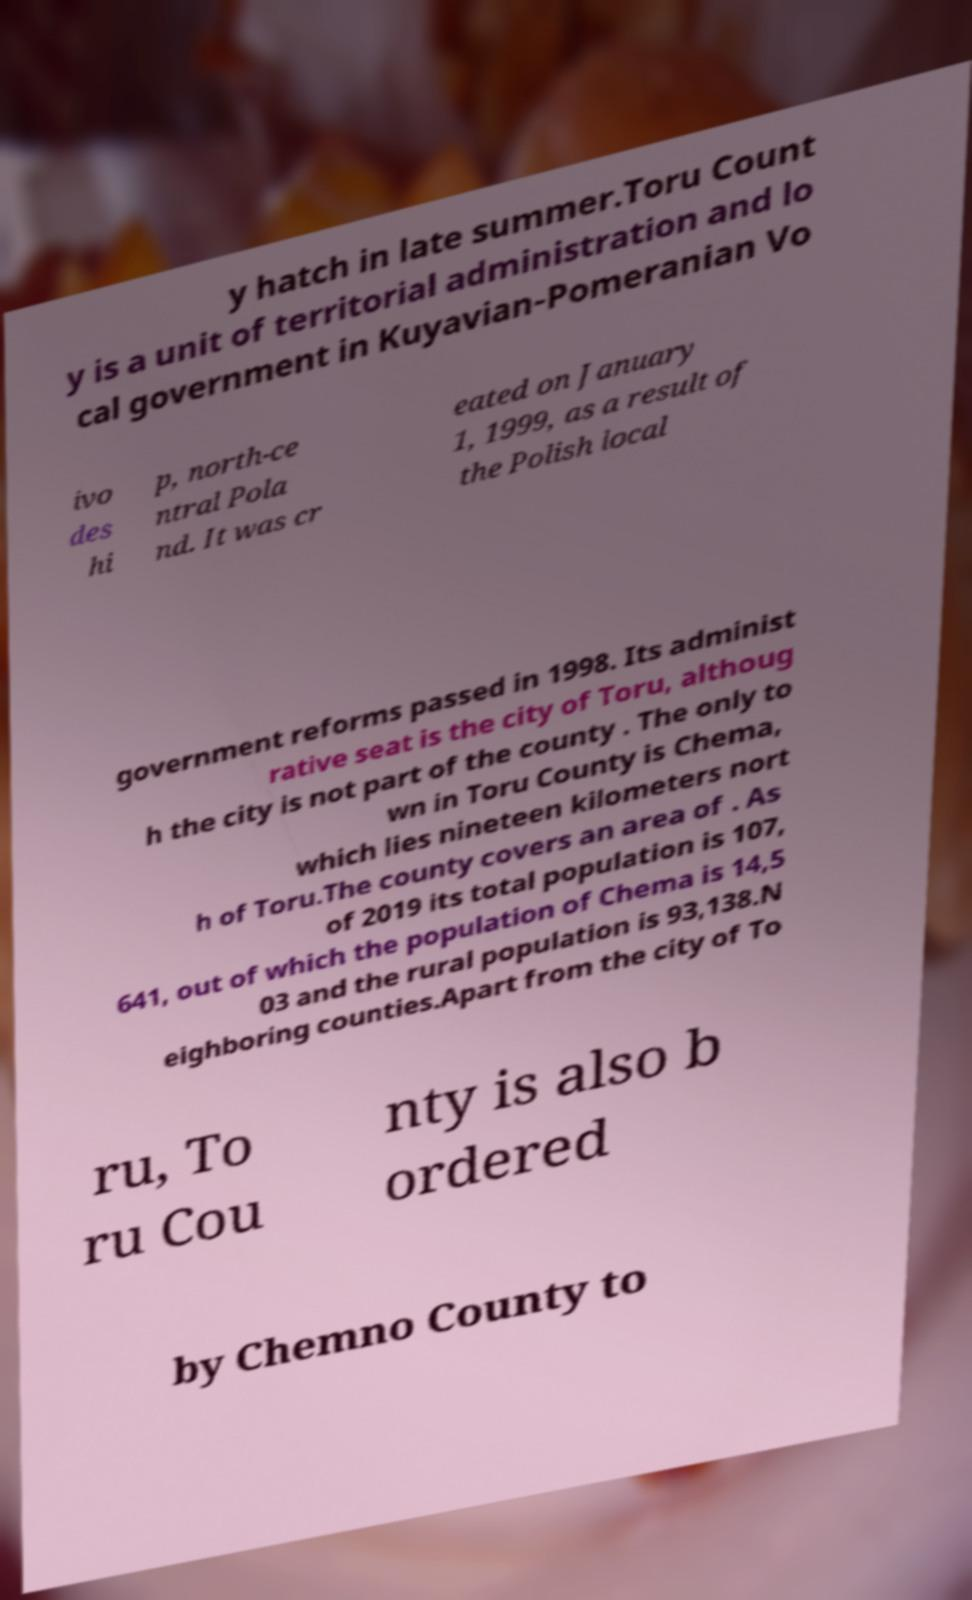There's text embedded in this image that I need extracted. Can you transcribe it verbatim? y hatch in late summer.Toru Count y is a unit of territorial administration and lo cal government in Kuyavian-Pomeranian Vo ivo des hi p, north-ce ntral Pola nd. It was cr eated on January 1, 1999, as a result of the Polish local government reforms passed in 1998. Its administ rative seat is the city of Toru, althoug h the city is not part of the county . The only to wn in Toru County is Chema, which lies nineteen kilometers nort h of Toru.The county covers an area of . As of 2019 its total population is 107, 641, out of which the population of Chema is 14,5 03 and the rural population is 93,138.N eighboring counties.Apart from the city of To ru, To ru Cou nty is also b ordered by Chemno County to 